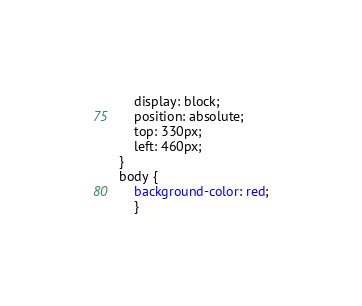<code> <loc_0><loc_0><loc_500><loc_500><_CSS_>	display: block;
	position: absolute;
	top: 330px;
	left: 460px;
}
body {
	background-color: red;
	}
</code> 